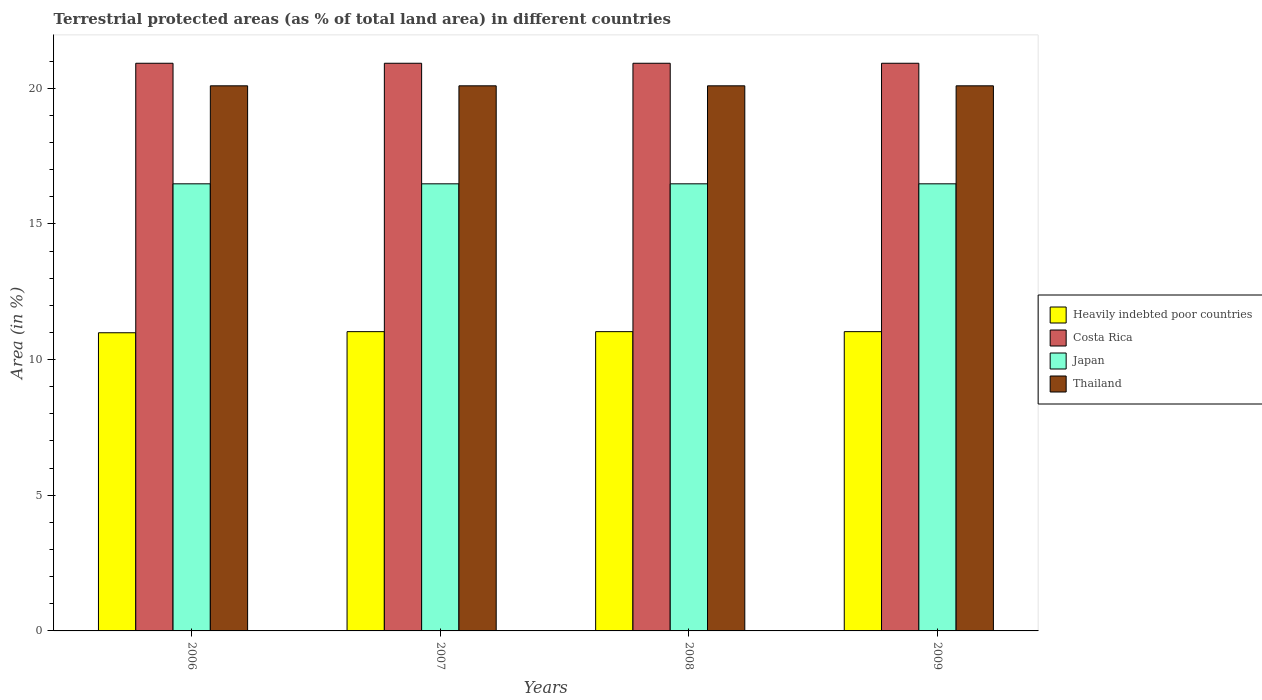Are the number of bars on each tick of the X-axis equal?
Make the answer very short. Yes. How many bars are there on the 4th tick from the right?
Ensure brevity in your answer.  4. What is the label of the 3rd group of bars from the left?
Your answer should be very brief. 2008. What is the percentage of terrestrial protected land in Thailand in 2007?
Offer a terse response. 20.09. Across all years, what is the maximum percentage of terrestrial protected land in Heavily indebted poor countries?
Ensure brevity in your answer.  11.03. Across all years, what is the minimum percentage of terrestrial protected land in Costa Rica?
Your answer should be compact. 20.92. In which year was the percentage of terrestrial protected land in Japan minimum?
Your answer should be compact. 2007. What is the total percentage of terrestrial protected land in Heavily indebted poor countries in the graph?
Your answer should be very brief. 44.08. What is the difference between the percentage of terrestrial protected land in Thailand in 2008 and the percentage of terrestrial protected land in Costa Rica in 2009?
Offer a very short reply. -0.83. What is the average percentage of terrestrial protected land in Costa Rica per year?
Make the answer very short. 20.92. In the year 2008, what is the difference between the percentage of terrestrial protected land in Japan and percentage of terrestrial protected land in Heavily indebted poor countries?
Your response must be concise. 5.45. In how many years, is the percentage of terrestrial protected land in Heavily indebted poor countries greater than 1 %?
Keep it short and to the point. 4. What is the ratio of the percentage of terrestrial protected land in Japan in 2006 to that in 2007?
Ensure brevity in your answer.  1. Is the percentage of terrestrial protected land in Thailand in 2008 less than that in 2009?
Your answer should be very brief. No. What is the difference between the highest and the second highest percentage of terrestrial protected land in Costa Rica?
Your answer should be compact. 0. What is the difference between the highest and the lowest percentage of terrestrial protected land in Heavily indebted poor countries?
Provide a succinct answer. 0.04. In how many years, is the percentage of terrestrial protected land in Thailand greater than the average percentage of terrestrial protected land in Thailand taken over all years?
Your answer should be compact. 0. Is the sum of the percentage of terrestrial protected land in Heavily indebted poor countries in 2007 and 2009 greater than the maximum percentage of terrestrial protected land in Thailand across all years?
Make the answer very short. Yes. Is it the case that in every year, the sum of the percentage of terrestrial protected land in Heavily indebted poor countries and percentage of terrestrial protected land in Thailand is greater than the sum of percentage of terrestrial protected land in Japan and percentage of terrestrial protected land in Costa Rica?
Your answer should be very brief. Yes. What does the 2nd bar from the left in 2007 represents?
Offer a very short reply. Costa Rica. Is it the case that in every year, the sum of the percentage of terrestrial protected land in Thailand and percentage of terrestrial protected land in Costa Rica is greater than the percentage of terrestrial protected land in Japan?
Provide a succinct answer. Yes. How many bars are there?
Offer a very short reply. 16. Are all the bars in the graph horizontal?
Your answer should be compact. No. How many years are there in the graph?
Offer a very short reply. 4. What is the difference between two consecutive major ticks on the Y-axis?
Offer a very short reply. 5. Are the values on the major ticks of Y-axis written in scientific E-notation?
Your answer should be very brief. No. How many legend labels are there?
Make the answer very short. 4. How are the legend labels stacked?
Make the answer very short. Vertical. What is the title of the graph?
Offer a very short reply. Terrestrial protected areas (as % of total land area) in different countries. What is the label or title of the X-axis?
Your response must be concise. Years. What is the label or title of the Y-axis?
Your response must be concise. Area (in %). What is the Area (in %) in Heavily indebted poor countries in 2006?
Offer a terse response. 10.99. What is the Area (in %) of Costa Rica in 2006?
Your answer should be very brief. 20.92. What is the Area (in %) of Japan in 2006?
Keep it short and to the point. 16.48. What is the Area (in %) of Thailand in 2006?
Your answer should be very brief. 20.09. What is the Area (in %) of Heavily indebted poor countries in 2007?
Your answer should be compact. 11.03. What is the Area (in %) of Costa Rica in 2007?
Provide a succinct answer. 20.92. What is the Area (in %) in Japan in 2007?
Make the answer very short. 16.48. What is the Area (in %) in Thailand in 2007?
Keep it short and to the point. 20.09. What is the Area (in %) of Heavily indebted poor countries in 2008?
Ensure brevity in your answer.  11.03. What is the Area (in %) of Costa Rica in 2008?
Provide a succinct answer. 20.92. What is the Area (in %) of Japan in 2008?
Provide a succinct answer. 16.48. What is the Area (in %) of Thailand in 2008?
Provide a short and direct response. 20.09. What is the Area (in %) in Heavily indebted poor countries in 2009?
Ensure brevity in your answer.  11.03. What is the Area (in %) of Costa Rica in 2009?
Give a very brief answer. 20.92. What is the Area (in %) in Japan in 2009?
Make the answer very short. 16.48. What is the Area (in %) of Thailand in 2009?
Your answer should be compact. 20.09. Across all years, what is the maximum Area (in %) in Heavily indebted poor countries?
Offer a very short reply. 11.03. Across all years, what is the maximum Area (in %) of Costa Rica?
Offer a terse response. 20.92. Across all years, what is the maximum Area (in %) in Japan?
Your response must be concise. 16.48. Across all years, what is the maximum Area (in %) in Thailand?
Offer a terse response. 20.09. Across all years, what is the minimum Area (in %) of Heavily indebted poor countries?
Your answer should be compact. 10.99. Across all years, what is the minimum Area (in %) in Costa Rica?
Provide a succinct answer. 20.92. Across all years, what is the minimum Area (in %) of Japan?
Give a very brief answer. 16.48. Across all years, what is the minimum Area (in %) of Thailand?
Offer a terse response. 20.09. What is the total Area (in %) of Heavily indebted poor countries in the graph?
Provide a short and direct response. 44.08. What is the total Area (in %) of Costa Rica in the graph?
Provide a short and direct response. 83.69. What is the total Area (in %) in Japan in the graph?
Offer a terse response. 65.91. What is the total Area (in %) in Thailand in the graph?
Keep it short and to the point. 80.36. What is the difference between the Area (in %) of Heavily indebted poor countries in 2006 and that in 2007?
Provide a succinct answer. -0.04. What is the difference between the Area (in %) in Costa Rica in 2006 and that in 2007?
Ensure brevity in your answer.  0. What is the difference between the Area (in %) in Heavily indebted poor countries in 2006 and that in 2008?
Make the answer very short. -0.04. What is the difference between the Area (in %) of Costa Rica in 2006 and that in 2008?
Offer a very short reply. 0. What is the difference between the Area (in %) of Japan in 2006 and that in 2008?
Your answer should be very brief. 0. What is the difference between the Area (in %) of Heavily indebted poor countries in 2006 and that in 2009?
Your answer should be compact. -0.04. What is the difference between the Area (in %) in Japan in 2006 and that in 2009?
Ensure brevity in your answer.  0. What is the difference between the Area (in %) in Thailand in 2006 and that in 2009?
Offer a very short reply. 0. What is the difference between the Area (in %) of Heavily indebted poor countries in 2007 and that in 2008?
Provide a short and direct response. 0. What is the difference between the Area (in %) in Japan in 2007 and that in 2008?
Provide a short and direct response. 0. What is the difference between the Area (in %) in Thailand in 2007 and that in 2008?
Give a very brief answer. 0. What is the difference between the Area (in %) of Japan in 2007 and that in 2009?
Your answer should be very brief. -0. What is the difference between the Area (in %) of Thailand in 2007 and that in 2009?
Make the answer very short. 0. What is the difference between the Area (in %) of Heavily indebted poor countries in 2008 and that in 2009?
Ensure brevity in your answer.  0. What is the difference between the Area (in %) of Costa Rica in 2008 and that in 2009?
Keep it short and to the point. 0. What is the difference between the Area (in %) in Japan in 2008 and that in 2009?
Ensure brevity in your answer.  -0. What is the difference between the Area (in %) of Heavily indebted poor countries in 2006 and the Area (in %) of Costa Rica in 2007?
Give a very brief answer. -9.93. What is the difference between the Area (in %) of Heavily indebted poor countries in 2006 and the Area (in %) of Japan in 2007?
Keep it short and to the point. -5.49. What is the difference between the Area (in %) in Heavily indebted poor countries in 2006 and the Area (in %) in Thailand in 2007?
Ensure brevity in your answer.  -9.1. What is the difference between the Area (in %) in Costa Rica in 2006 and the Area (in %) in Japan in 2007?
Ensure brevity in your answer.  4.44. What is the difference between the Area (in %) in Costa Rica in 2006 and the Area (in %) in Thailand in 2007?
Make the answer very short. 0.83. What is the difference between the Area (in %) in Japan in 2006 and the Area (in %) in Thailand in 2007?
Make the answer very short. -3.61. What is the difference between the Area (in %) in Heavily indebted poor countries in 2006 and the Area (in %) in Costa Rica in 2008?
Your response must be concise. -9.93. What is the difference between the Area (in %) in Heavily indebted poor countries in 2006 and the Area (in %) in Japan in 2008?
Ensure brevity in your answer.  -5.49. What is the difference between the Area (in %) of Heavily indebted poor countries in 2006 and the Area (in %) of Thailand in 2008?
Your answer should be compact. -9.1. What is the difference between the Area (in %) in Costa Rica in 2006 and the Area (in %) in Japan in 2008?
Keep it short and to the point. 4.44. What is the difference between the Area (in %) of Costa Rica in 2006 and the Area (in %) of Thailand in 2008?
Offer a terse response. 0.83. What is the difference between the Area (in %) in Japan in 2006 and the Area (in %) in Thailand in 2008?
Keep it short and to the point. -3.61. What is the difference between the Area (in %) of Heavily indebted poor countries in 2006 and the Area (in %) of Costa Rica in 2009?
Provide a short and direct response. -9.93. What is the difference between the Area (in %) in Heavily indebted poor countries in 2006 and the Area (in %) in Japan in 2009?
Keep it short and to the point. -5.49. What is the difference between the Area (in %) of Heavily indebted poor countries in 2006 and the Area (in %) of Thailand in 2009?
Your response must be concise. -9.1. What is the difference between the Area (in %) in Costa Rica in 2006 and the Area (in %) in Japan in 2009?
Provide a short and direct response. 4.44. What is the difference between the Area (in %) of Costa Rica in 2006 and the Area (in %) of Thailand in 2009?
Make the answer very short. 0.83. What is the difference between the Area (in %) of Japan in 2006 and the Area (in %) of Thailand in 2009?
Your answer should be compact. -3.61. What is the difference between the Area (in %) of Heavily indebted poor countries in 2007 and the Area (in %) of Costa Rica in 2008?
Keep it short and to the point. -9.89. What is the difference between the Area (in %) in Heavily indebted poor countries in 2007 and the Area (in %) in Japan in 2008?
Make the answer very short. -5.45. What is the difference between the Area (in %) of Heavily indebted poor countries in 2007 and the Area (in %) of Thailand in 2008?
Your answer should be compact. -9.06. What is the difference between the Area (in %) of Costa Rica in 2007 and the Area (in %) of Japan in 2008?
Offer a very short reply. 4.44. What is the difference between the Area (in %) of Costa Rica in 2007 and the Area (in %) of Thailand in 2008?
Provide a short and direct response. 0.83. What is the difference between the Area (in %) of Japan in 2007 and the Area (in %) of Thailand in 2008?
Ensure brevity in your answer.  -3.61. What is the difference between the Area (in %) in Heavily indebted poor countries in 2007 and the Area (in %) in Costa Rica in 2009?
Your answer should be very brief. -9.89. What is the difference between the Area (in %) in Heavily indebted poor countries in 2007 and the Area (in %) in Japan in 2009?
Ensure brevity in your answer.  -5.45. What is the difference between the Area (in %) of Heavily indebted poor countries in 2007 and the Area (in %) of Thailand in 2009?
Give a very brief answer. -9.06. What is the difference between the Area (in %) of Costa Rica in 2007 and the Area (in %) of Japan in 2009?
Provide a short and direct response. 4.44. What is the difference between the Area (in %) in Costa Rica in 2007 and the Area (in %) in Thailand in 2009?
Keep it short and to the point. 0.83. What is the difference between the Area (in %) of Japan in 2007 and the Area (in %) of Thailand in 2009?
Keep it short and to the point. -3.61. What is the difference between the Area (in %) of Heavily indebted poor countries in 2008 and the Area (in %) of Costa Rica in 2009?
Provide a short and direct response. -9.89. What is the difference between the Area (in %) in Heavily indebted poor countries in 2008 and the Area (in %) in Japan in 2009?
Your answer should be compact. -5.45. What is the difference between the Area (in %) in Heavily indebted poor countries in 2008 and the Area (in %) in Thailand in 2009?
Offer a terse response. -9.06. What is the difference between the Area (in %) of Costa Rica in 2008 and the Area (in %) of Japan in 2009?
Your answer should be compact. 4.44. What is the difference between the Area (in %) in Costa Rica in 2008 and the Area (in %) in Thailand in 2009?
Make the answer very short. 0.83. What is the difference between the Area (in %) in Japan in 2008 and the Area (in %) in Thailand in 2009?
Make the answer very short. -3.61. What is the average Area (in %) of Heavily indebted poor countries per year?
Keep it short and to the point. 11.02. What is the average Area (in %) of Costa Rica per year?
Give a very brief answer. 20.92. What is the average Area (in %) in Japan per year?
Ensure brevity in your answer.  16.48. What is the average Area (in %) of Thailand per year?
Your answer should be very brief. 20.09. In the year 2006, what is the difference between the Area (in %) in Heavily indebted poor countries and Area (in %) in Costa Rica?
Offer a very short reply. -9.93. In the year 2006, what is the difference between the Area (in %) of Heavily indebted poor countries and Area (in %) of Japan?
Keep it short and to the point. -5.49. In the year 2006, what is the difference between the Area (in %) in Heavily indebted poor countries and Area (in %) in Thailand?
Ensure brevity in your answer.  -9.1. In the year 2006, what is the difference between the Area (in %) of Costa Rica and Area (in %) of Japan?
Your response must be concise. 4.44. In the year 2006, what is the difference between the Area (in %) of Costa Rica and Area (in %) of Thailand?
Offer a very short reply. 0.83. In the year 2006, what is the difference between the Area (in %) of Japan and Area (in %) of Thailand?
Ensure brevity in your answer.  -3.61. In the year 2007, what is the difference between the Area (in %) in Heavily indebted poor countries and Area (in %) in Costa Rica?
Your answer should be very brief. -9.89. In the year 2007, what is the difference between the Area (in %) of Heavily indebted poor countries and Area (in %) of Japan?
Your answer should be compact. -5.45. In the year 2007, what is the difference between the Area (in %) in Heavily indebted poor countries and Area (in %) in Thailand?
Offer a terse response. -9.06. In the year 2007, what is the difference between the Area (in %) of Costa Rica and Area (in %) of Japan?
Your answer should be very brief. 4.44. In the year 2007, what is the difference between the Area (in %) of Costa Rica and Area (in %) of Thailand?
Your response must be concise. 0.83. In the year 2007, what is the difference between the Area (in %) in Japan and Area (in %) in Thailand?
Provide a short and direct response. -3.61. In the year 2008, what is the difference between the Area (in %) of Heavily indebted poor countries and Area (in %) of Costa Rica?
Make the answer very short. -9.89. In the year 2008, what is the difference between the Area (in %) in Heavily indebted poor countries and Area (in %) in Japan?
Make the answer very short. -5.45. In the year 2008, what is the difference between the Area (in %) of Heavily indebted poor countries and Area (in %) of Thailand?
Ensure brevity in your answer.  -9.06. In the year 2008, what is the difference between the Area (in %) of Costa Rica and Area (in %) of Japan?
Your answer should be very brief. 4.44. In the year 2008, what is the difference between the Area (in %) in Costa Rica and Area (in %) in Thailand?
Your answer should be very brief. 0.83. In the year 2008, what is the difference between the Area (in %) in Japan and Area (in %) in Thailand?
Your answer should be compact. -3.61. In the year 2009, what is the difference between the Area (in %) in Heavily indebted poor countries and Area (in %) in Costa Rica?
Provide a succinct answer. -9.89. In the year 2009, what is the difference between the Area (in %) of Heavily indebted poor countries and Area (in %) of Japan?
Keep it short and to the point. -5.45. In the year 2009, what is the difference between the Area (in %) of Heavily indebted poor countries and Area (in %) of Thailand?
Offer a very short reply. -9.06. In the year 2009, what is the difference between the Area (in %) of Costa Rica and Area (in %) of Japan?
Give a very brief answer. 4.44. In the year 2009, what is the difference between the Area (in %) in Costa Rica and Area (in %) in Thailand?
Keep it short and to the point. 0.83. In the year 2009, what is the difference between the Area (in %) of Japan and Area (in %) of Thailand?
Offer a terse response. -3.61. What is the ratio of the Area (in %) in Japan in 2006 to that in 2007?
Ensure brevity in your answer.  1. What is the ratio of the Area (in %) of Heavily indebted poor countries in 2006 to that in 2008?
Give a very brief answer. 1. What is the ratio of the Area (in %) of Thailand in 2006 to that in 2008?
Provide a succinct answer. 1. What is the ratio of the Area (in %) in Heavily indebted poor countries in 2006 to that in 2009?
Your response must be concise. 1. What is the ratio of the Area (in %) in Costa Rica in 2006 to that in 2009?
Your answer should be compact. 1. What is the ratio of the Area (in %) of Thailand in 2006 to that in 2009?
Make the answer very short. 1. What is the ratio of the Area (in %) in Costa Rica in 2007 to that in 2008?
Provide a short and direct response. 1. What is the ratio of the Area (in %) of Japan in 2007 to that in 2008?
Keep it short and to the point. 1. What is the ratio of the Area (in %) in Costa Rica in 2007 to that in 2009?
Make the answer very short. 1. What is the ratio of the Area (in %) of Thailand in 2007 to that in 2009?
Give a very brief answer. 1. What is the ratio of the Area (in %) in Heavily indebted poor countries in 2008 to that in 2009?
Provide a succinct answer. 1. What is the ratio of the Area (in %) in Japan in 2008 to that in 2009?
Provide a short and direct response. 1. What is the ratio of the Area (in %) in Thailand in 2008 to that in 2009?
Provide a short and direct response. 1. What is the difference between the highest and the second highest Area (in %) in Heavily indebted poor countries?
Offer a terse response. 0. What is the difference between the highest and the second highest Area (in %) of Costa Rica?
Offer a terse response. 0. What is the difference between the highest and the second highest Area (in %) of Thailand?
Your response must be concise. 0. What is the difference between the highest and the lowest Area (in %) in Heavily indebted poor countries?
Keep it short and to the point. 0.04. What is the difference between the highest and the lowest Area (in %) of Japan?
Provide a short and direct response. 0. 